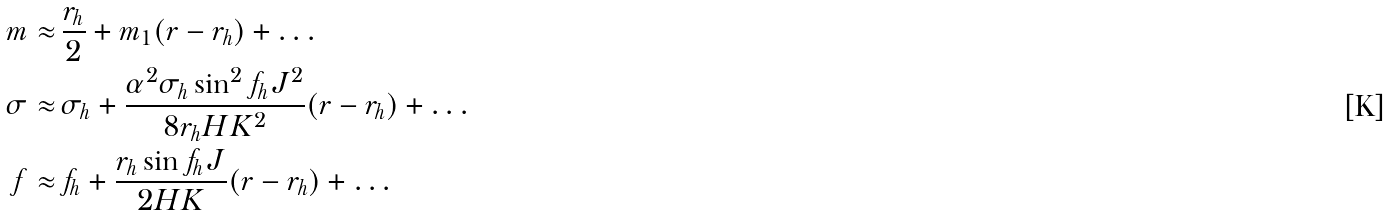Convert formula to latex. <formula><loc_0><loc_0><loc_500><loc_500>m \approx & \, \frac { r _ { h } } { 2 } + m _ { 1 } ( r - r _ { h } ) + \dots \\ \sigma \approx & \, \sigma _ { h } + \frac { \alpha ^ { 2 } \sigma _ { h } \sin ^ { 2 } f _ { h } J ^ { 2 } } { 8 r _ { h } H K ^ { 2 } } ( r - r _ { h } ) + \dots \\ f \approx & \, f _ { h } + \frac { r _ { h } \sin f _ { h } J } { 2 H K } ( r - r _ { h } ) + \dots</formula> 